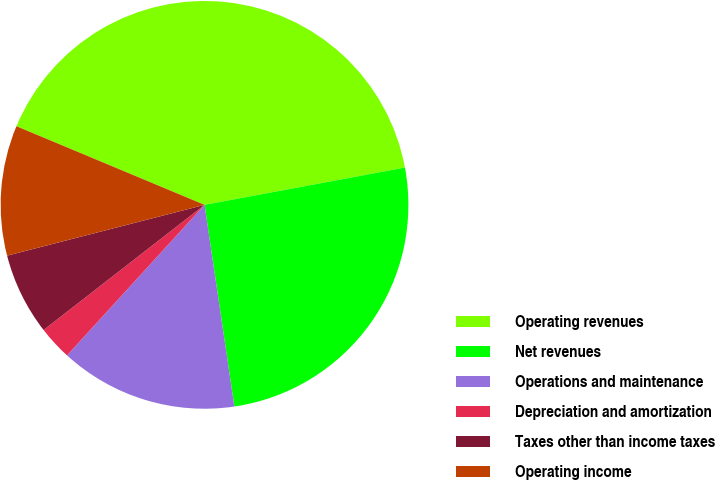Convert chart. <chart><loc_0><loc_0><loc_500><loc_500><pie_chart><fcel>Operating revenues<fcel>Net revenues<fcel>Operations and maintenance<fcel>Depreciation and amortization<fcel>Taxes other than income taxes<fcel>Operating income<nl><fcel>40.77%<fcel>25.59%<fcel>14.12%<fcel>2.7%<fcel>6.51%<fcel>10.31%<nl></chart> 